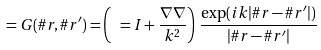Convert formula to latex. <formula><loc_0><loc_0><loc_500><loc_500>\ = G ( \# r , \# r ^ { \prime } ) = \left ( \ = I + \frac { \nabla \nabla } { k ^ { 2 } } \right ) \, \frac { \exp ( { i k | \# r - \# r ^ { \prime } | } ) } { | \# r - \# r ^ { \prime } | }</formula> 